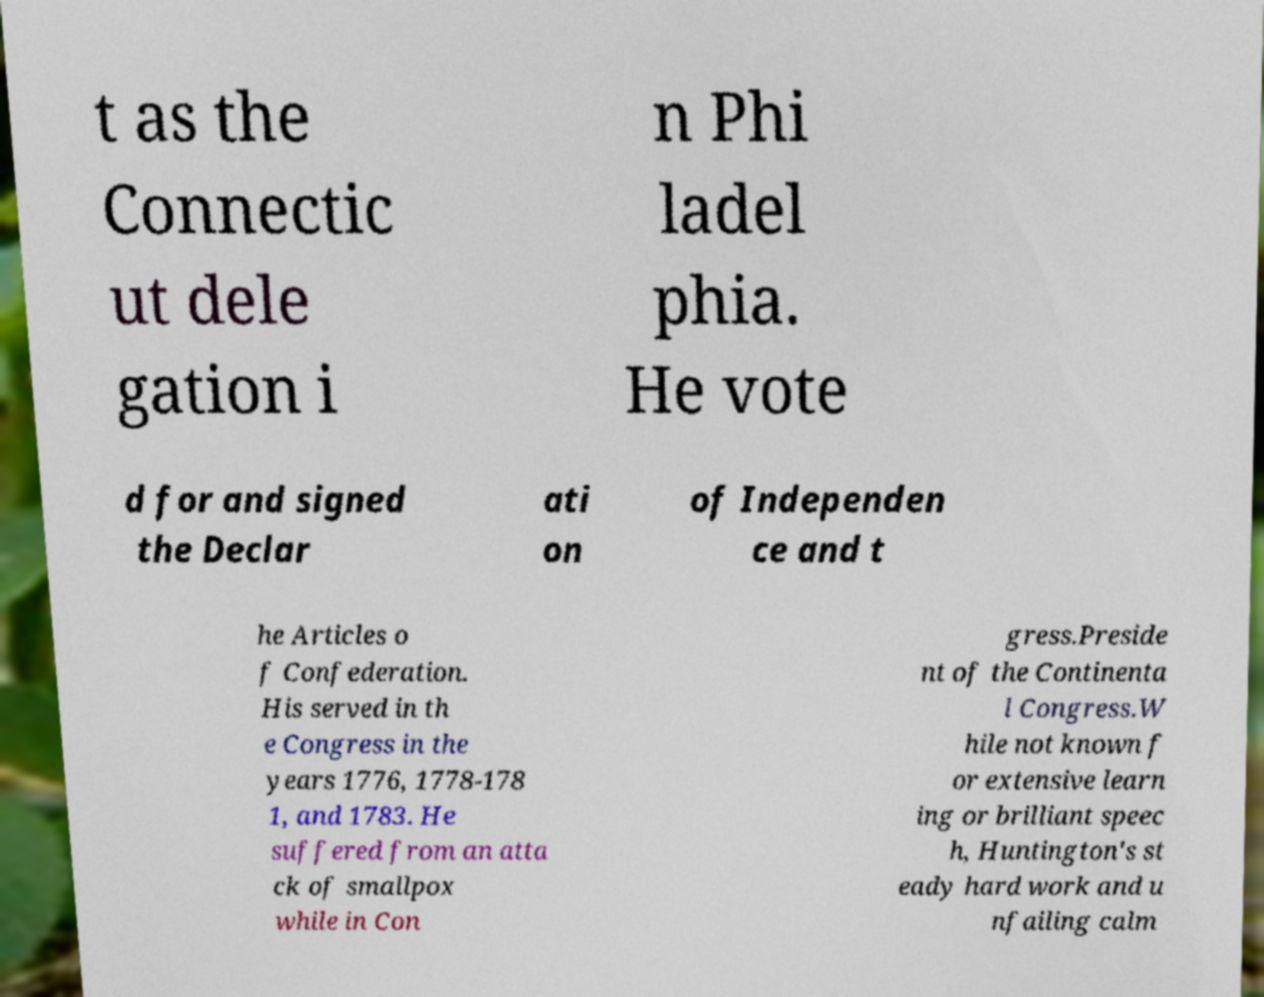For documentation purposes, I need the text within this image transcribed. Could you provide that? t as the Connectic ut dele gation i n Phi ladel phia. He vote d for and signed the Declar ati on of Independen ce and t he Articles o f Confederation. His served in th e Congress in the years 1776, 1778-178 1, and 1783. He suffered from an atta ck of smallpox while in Con gress.Preside nt of the Continenta l Congress.W hile not known f or extensive learn ing or brilliant speec h, Huntington's st eady hard work and u nfailing calm 